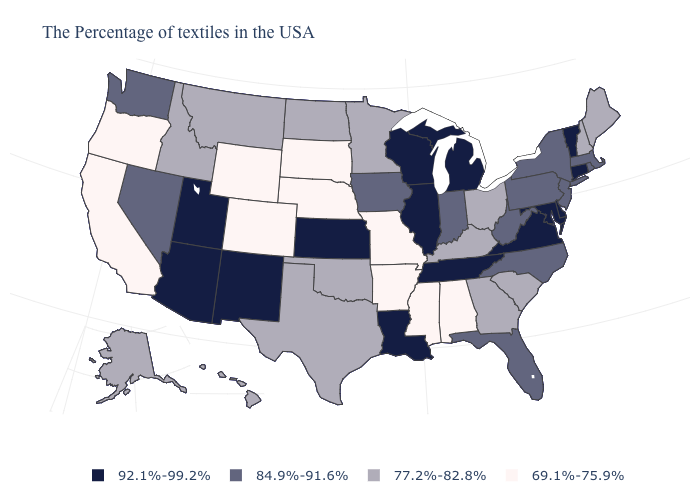Does Arkansas have the lowest value in the USA?
Write a very short answer. Yes. Name the states that have a value in the range 77.2%-82.8%?
Concise answer only. Maine, New Hampshire, South Carolina, Ohio, Georgia, Kentucky, Minnesota, Oklahoma, Texas, North Dakota, Montana, Idaho, Alaska, Hawaii. Name the states that have a value in the range 69.1%-75.9%?
Give a very brief answer. Alabama, Mississippi, Missouri, Arkansas, Nebraska, South Dakota, Wyoming, Colorado, California, Oregon. What is the lowest value in states that border Virginia?
Answer briefly. 77.2%-82.8%. What is the value of Missouri?
Keep it brief. 69.1%-75.9%. What is the value of Alabama?
Answer briefly. 69.1%-75.9%. Name the states that have a value in the range 92.1%-99.2%?
Write a very short answer. Vermont, Connecticut, Delaware, Maryland, Virginia, Michigan, Tennessee, Wisconsin, Illinois, Louisiana, Kansas, New Mexico, Utah, Arizona. What is the value of Arizona?
Answer briefly. 92.1%-99.2%. Name the states that have a value in the range 69.1%-75.9%?
Concise answer only. Alabama, Mississippi, Missouri, Arkansas, Nebraska, South Dakota, Wyoming, Colorado, California, Oregon. Name the states that have a value in the range 69.1%-75.9%?
Keep it brief. Alabama, Mississippi, Missouri, Arkansas, Nebraska, South Dakota, Wyoming, Colorado, California, Oregon. What is the highest value in states that border Oregon?
Short answer required. 84.9%-91.6%. Name the states that have a value in the range 77.2%-82.8%?
Concise answer only. Maine, New Hampshire, South Carolina, Ohio, Georgia, Kentucky, Minnesota, Oklahoma, Texas, North Dakota, Montana, Idaho, Alaska, Hawaii. Name the states that have a value in the range 92.1%-99.2%?
Concise answer only. Vermont, Connecticut, Delaware, Maryland, Virginia, Michigan, Tennessee, Wisconsin, Illinois, Louisiana, Kansas, New Mexico, Utah, Arizona. What is the highest value in states that border Illinois?
Write a very short answer. 92.1%-99.2%. Which states have the lowest value in the Northeast?
Write a very short answer. Maine, New Hampshire. 